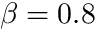<formula> <loc_0><loc_0><loc_500><loc_500>\beta = 0 . 8</formula> 